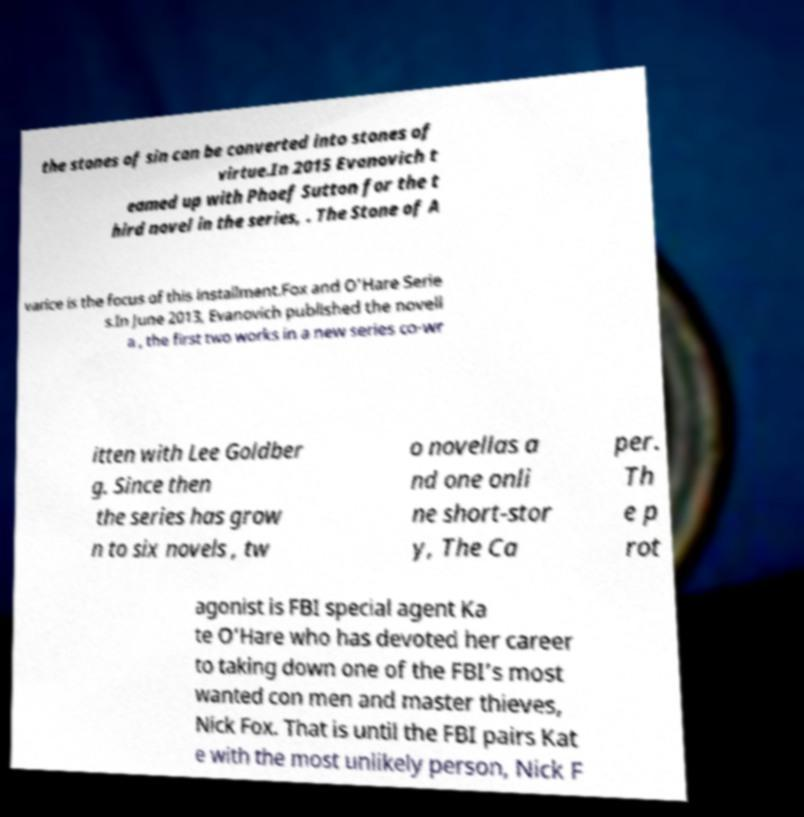Can you read and provide the text displayed in the image?This photo seems to have some interesting text. Can you extract and type it out for me? the stones of sin can be converted into stones of virtue.In 2015 Evanovich t eamed up with Phoef Sutton for the t hird novel in the series, . The Stone of A varice is the focus of this installment.Fox and O'Hare Serie s.In June 2013, Evanovich published the novell a , the first two works in a new series co-wr itten with Lee Goldber g. Since then the series has grow n to six novels , tw o novellas a nd one onli ne short-stor y, The Ca per. Th e p rot agonist is FBI special agent Ka te O’Hare who has devoted her career to taking down one of the FBI’s most wanted con men and master thieves, Nick Fox. That is until the FBI pairs Kat e with the most unlikely person, Nick F 